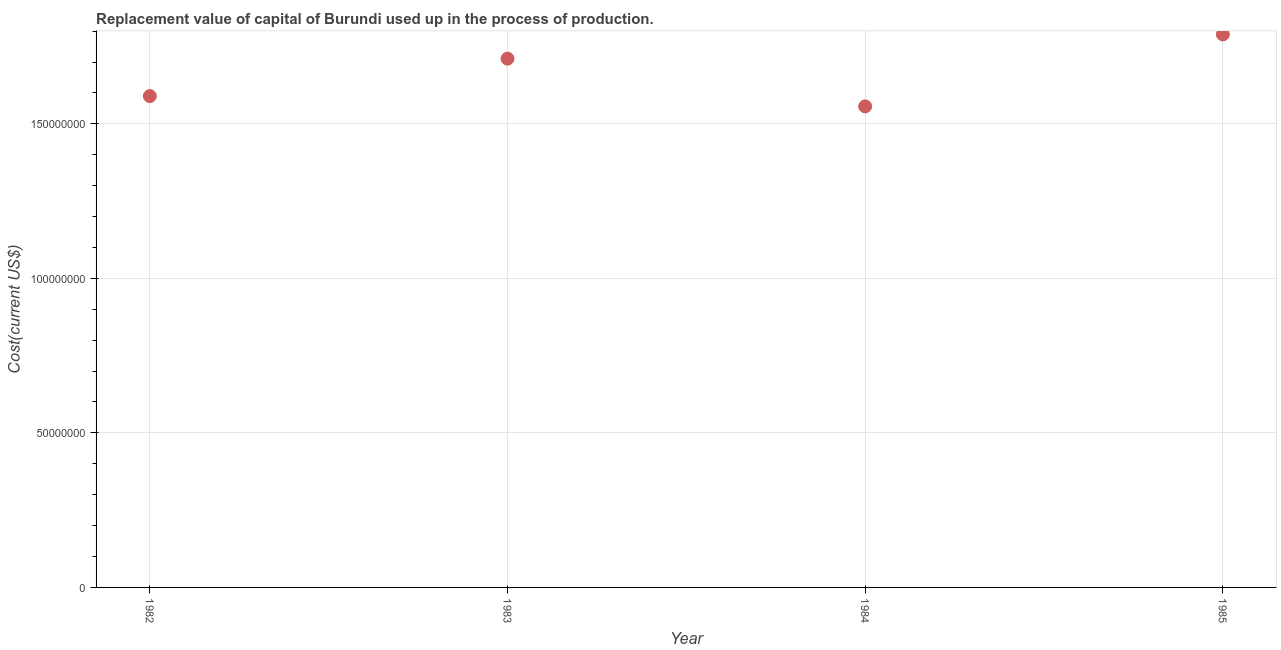What is the consumption of fixed capital in 1984?
Keep it short and to the point. 1.56e+08. Across all years, what is the maximum consumption of fixed capital?
Ensure brevity in your answer.  1.79e+08. Across all years, what is the minimum consumption of fixed capital?
Your answer should be very brief. 1.56e+08. What is the sum of the consumption of fixed capital?
Provide a short and direct response. 6.65e+08. What is the difference between the consumption of fixed capital in 1982 and 1984?
Your answer should be very brief. 3.33e+06. What is the average consumption of fixed capital per year?
Provide a short and direct response. 1.66e+08. What is the median consumption of fixed capital?
Keep it short and to the point. 1.65e+08. In how many years, is the consumption of fixed capital greater than 40000000 US$?
Make the answer very short. 4. Do a majority of the years between 1982 and 1984 (inclusive) have consumption of fixed capital greater than 40000000 US$?
Your answer should be very brief. Yes. What is the ratio of the consumption of fixed capital in 1982 to that in 1985?
Offer a very short reply. 0.89. Is the consumption of fixed capital in 1984 less than that in 1985?
Keep it short and to the point. Yes. Is the difference between the consumption of fixed capital in 1982 and 1984 greater than the difference between any two years?
Offer a very short reply. No. What is the difference between the highest and the second highest consumption of fixed capital?
Provide a succinct answer. 7.84e+06. Is the sum of the consumption of fixed capital in 1984 and 1985 greater than the maximum consumption of fixed capital across all years?
Your answer should be compact. Yes. What is the difference between the highest and the lowest consumption of fixed capital?
Your response must be concise. 2.33e+07. In how many years, is the consumption of fixed capital greater than the average consumption of fixed capital taken over all years?
Your answer should be very brief. 2. Does the consumption of fixed capital monotonically increase over the years?
Provide a short and direct response. No. What is the difference between two consecutive major ticks on the Y-axis?
Your answer should be very brief. 5.00e+07. Does the graph contain grids?
Give a very brief answer. Yes. What is the title of the graph?
Offer a terse response. Replacement value of capital of Burundi used up in the process of production. What is the label or title of the Y-axis?
Your response must be concise. Cost(current US$). What is the Cost(current US$) in 1982?
Provide a short and direct response. 1.59e+08. What is the Cost(current US$) in 1983?
Offer a terse response. 1.71e+08. What is the Cost(current US$) in 1984?
Your answer should be very brief. 1.56e+08. What is the Cost(current US$) in 1985?
Keep it short and to the point. 1.79e+08. What is the difference between the Cost(current US$) in 1982 and 1983?
Keep it short and to the point. -1.21e+07. What is the difference between the Cost(current US$) in 1982 and 1984?
Provide a short and direct response. 3.33e+06. What is the difference between the Cost(current US$) in 1982 and 1985?
Provide a succinct answer. -2.00e+07. What is the difference between the Cost(current US$) in 1983 and 1984?
Make the answer very short. 1.54e+07. What is the difference between the Cost(current US$) in 1983 and 1985?
Your response must be concise. -7.84e+06. What is the difference between the Cost(current US$) in 1984 and 1985?
Your answer should be very brief. -2.33e+07. What is the ratio of the Cost(current US$) in 1982 to that in 1983?
Your answer should be compact. 0.93. What is the ratio of the Cost(current US$) in 1982 to that in 1984?
Ensure brevity in your answer.  1.02. What is the ratio of the Cost(current US$) in 1982 to that in 1985?
Your response must be concise. 0.89. What is the ratio of the Cost(current US$) in 1983 to that in 1984?
Provide a short and direct response. 1.1. What is the ratio of the Cost(current US$) in 1983 to that in 1985?
Give a very brief answer. 0.96. What is the ratio of the Cost(current US$) in 1984 to that in 1985?
Provide a succinct answer. 0.87. 